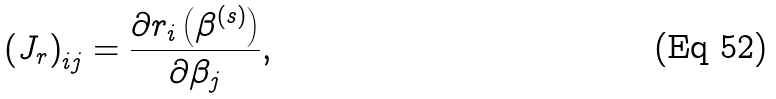Convert formula to latex. <formula><loc_0><loc_0><loc_500><loc_500>\left ( J _ { r } \right ) _ { i j } = { \frac { \partial r _ { i } \left ( { \beta } ^ { ( s ) } \right ) } { \partial \beta _ { j } } } ,</formula> 